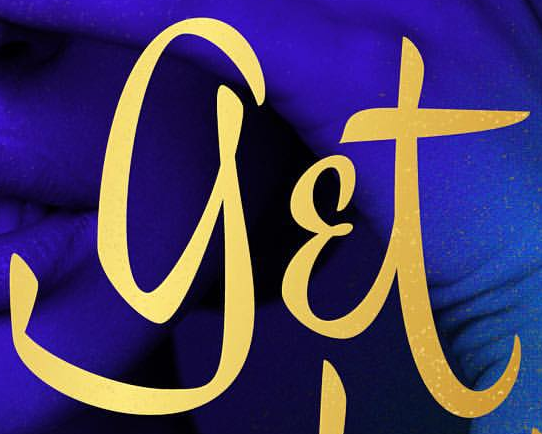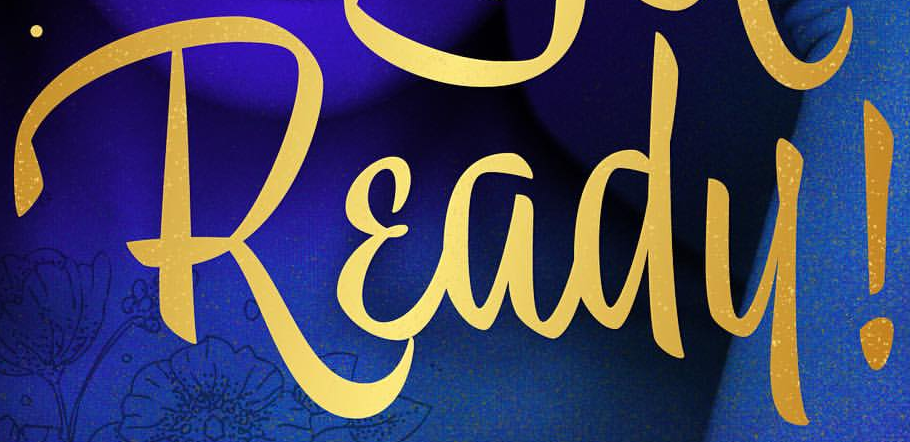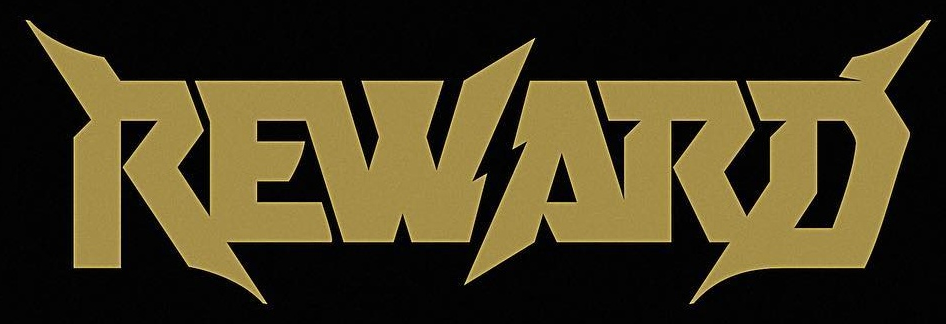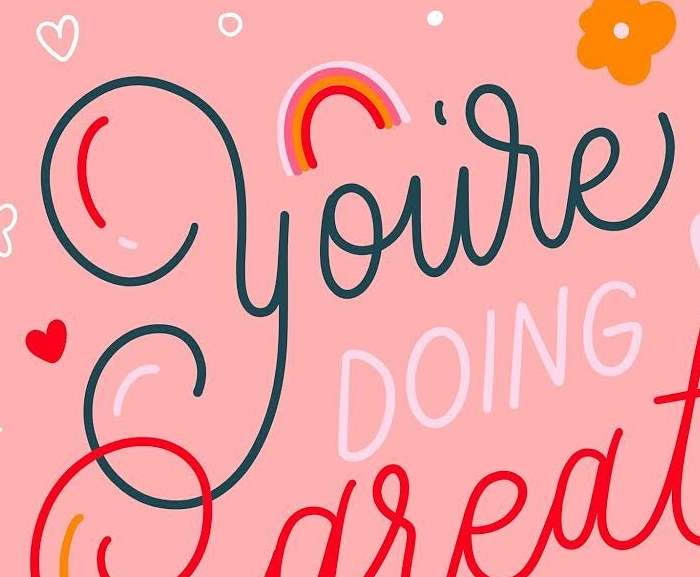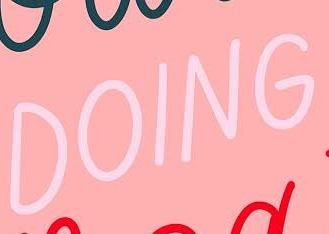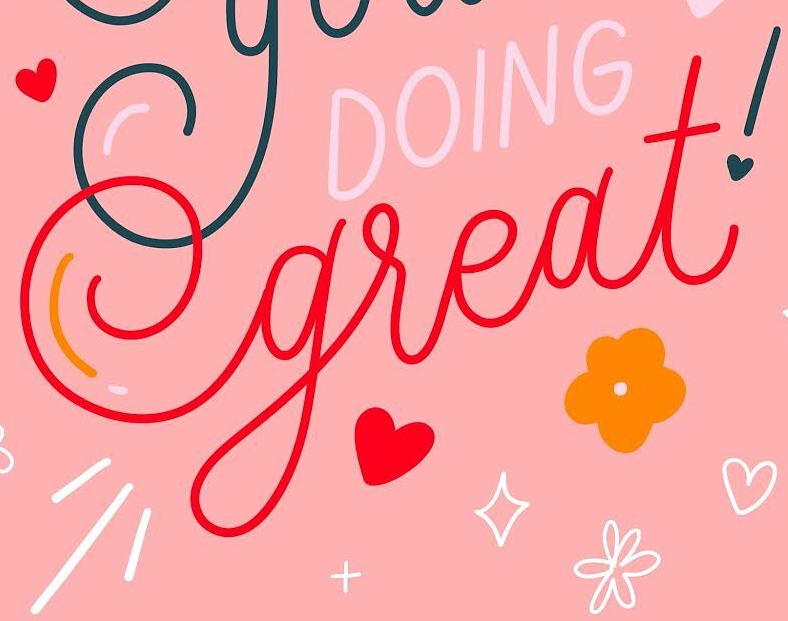Transcribe the words shown in these images in order, separated by a semicolon. get; Ready!; REWARD; you're; DOING; great! 